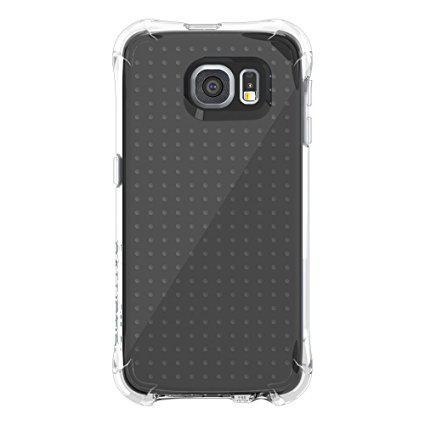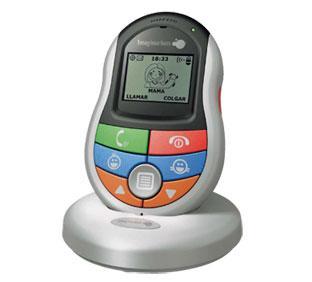The first image is the image on the left, the second image is the image on the right. For the images displayed, is the sentence "There are two phones and one of them is ovalish." factually correct? Answer yes or no. Yes. The first image is the image on the left, the second image is the image on the right. Given the left and right images, does the statement "There is a colorful remote control with non-grid buttons in one image, and a black piece of electronics in the other." hold true? Answer yes or no. Yes. 